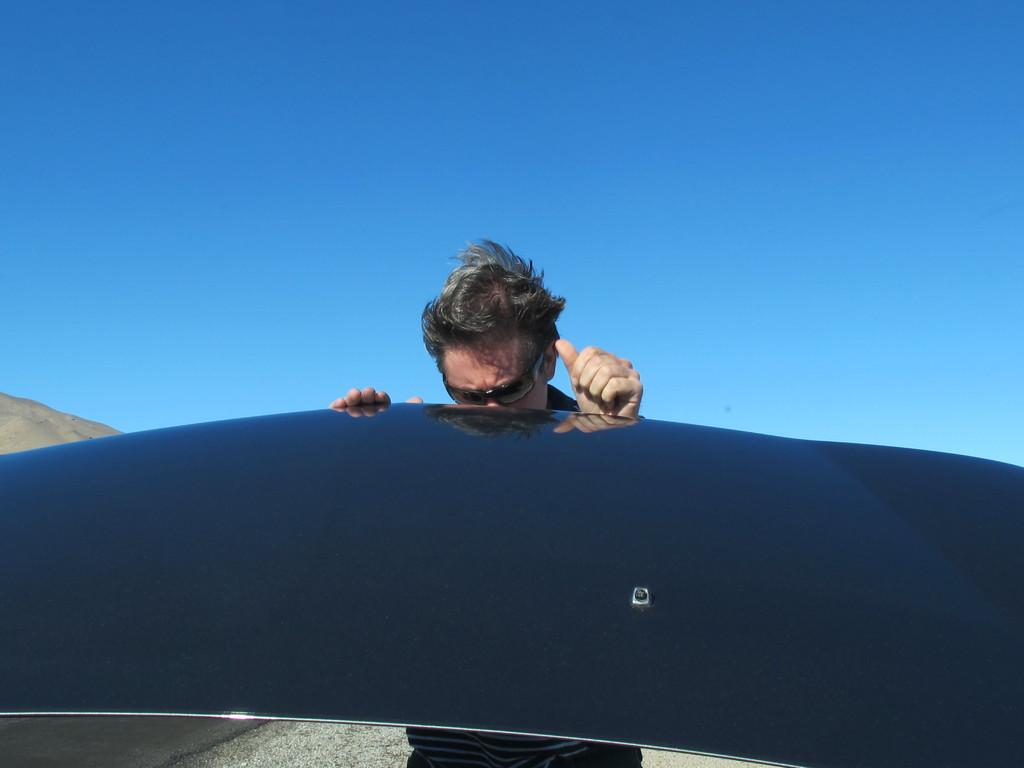What is the main subject of the image? There is a person standing in the image. What is the person holding in the image? The person is holding an object. What can be seen in the background of the image? The sky is visible in the background of the image. What is the color of the sky in the image? The color of the sky is blue. What type of toothbrush is being used to distribute the object in the image? There is no toothbrush or distribution of objects present in the image. 